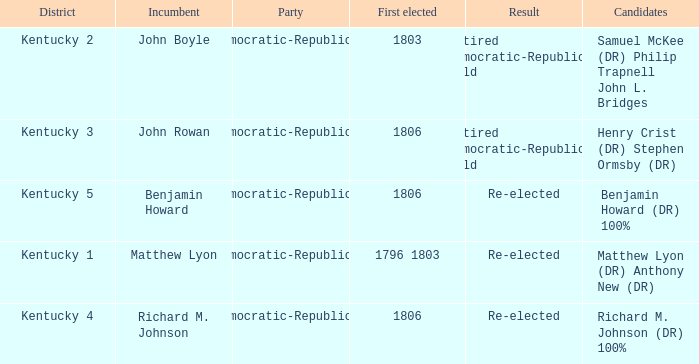Name the first elected for kentucky 1 1796 1803. 